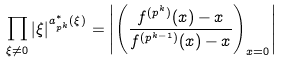<formula> <loc_0><loc_0><loc_500><loc_500>\prod _ { \xi \neq 0 } | \xi | ^ { a _ { p ^ { k } } ^ { * } ( \xi ) } = \left | \left ( \frac { f ^ { ( p ^ { k } ) } ( x ) - x } { f ^ { ( p ^ { k - 1 } ) } ( x ) - x } \right ) _ { x = 0 } \right |</formula> 